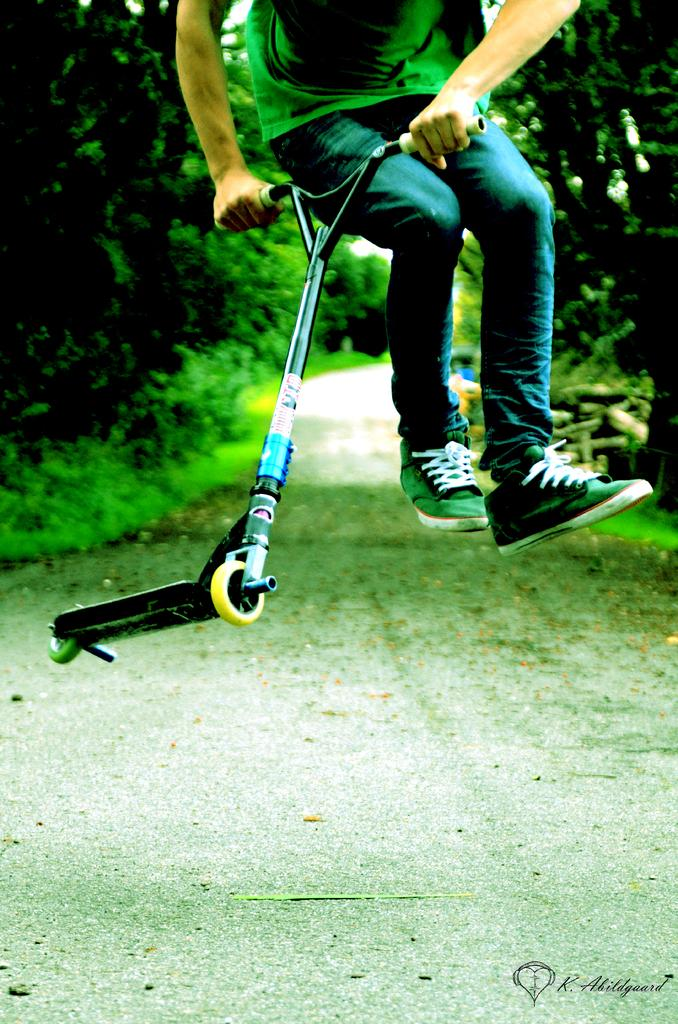What can be seen running through the landscape in the image? There is a path in the image. What type of vegetation is present alongside the path? Grass, plants, and trees are visible on either side of the path. What is the person in the image doing? The person is jumping and holding a cycle handle. What type of jeans is the person wearing in the image? There is no information about the person's clothing in the image, so we cannot determine if they are wearing jeans or any other type of clothing. How many sisters are present in the image? There is no mention of any sisters in the image; only one person is visible. 